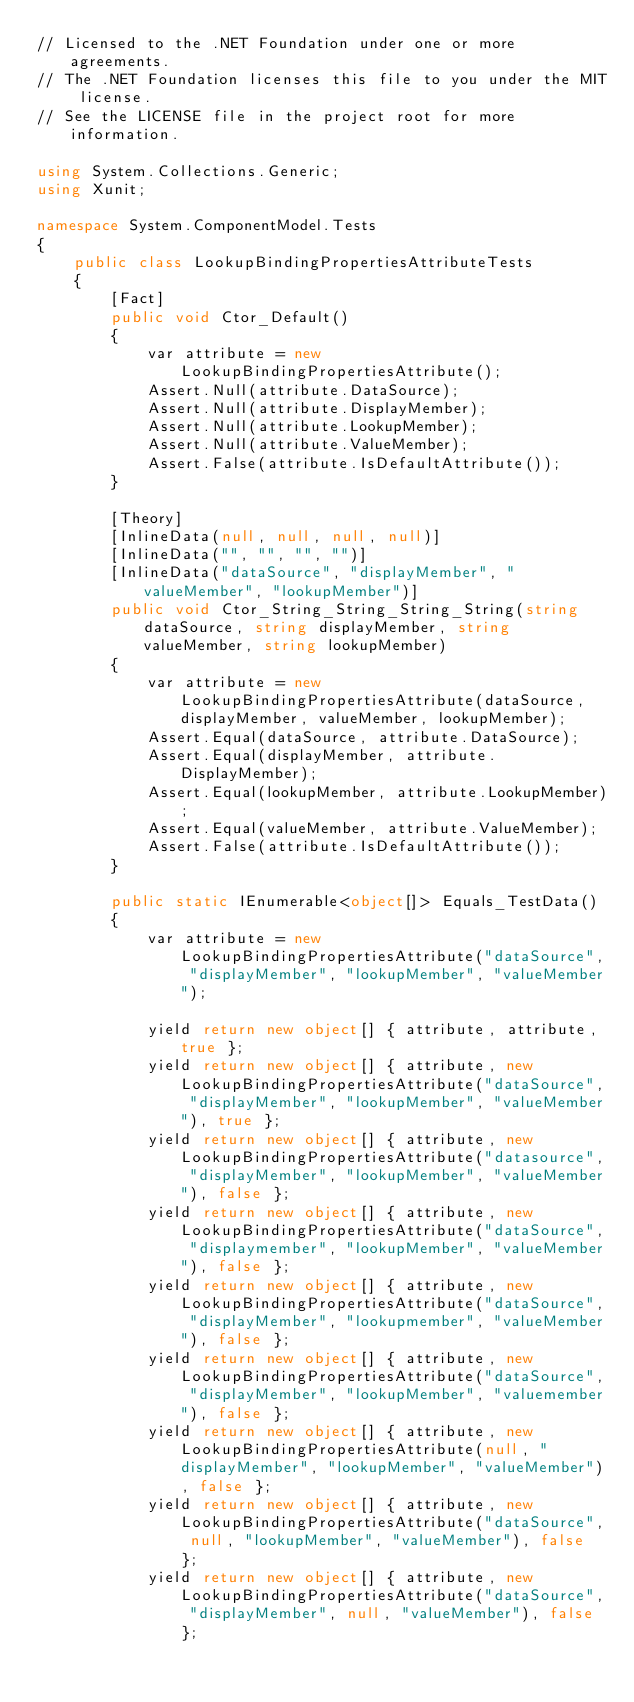<code> <loc_0><loc_0><loc_500><loc_500><_C#_>// Licensed to the .NET Foundation under one or more agreements.
// The .NET Foundation licenses this file to you under the MIT license.
// See the LICENSE file in the project root for more information.

using System.Collections.Generic;
using Xunit;

namespace System.ComponentModel.Tests
{
    public class LookupBindingPropertiesAttributeTests
    {
        [Fact]
        public void Ctor_Default()
        {
            var attribute = new LookupBindingPropertiesAttribute();
            Assert.Null(attribute.DataSource);
            Assert.Null(attribute.DisplayMember);
            Assert.Null(attribute.LookupMember);
            Assert.Null(attribute.ValueMember);
            Assert.False(attribute.IsDefaultAttribute());
        }

        [Theory]
        [InlineData(null, null, null, null)]
        [InlineData("", "", "", "")]
        [InlineData("dataSource", "displayMember", "valueMember", "lookupMember")]
        public void Ctor_String_String_String_String(string dataSource, string displayMember, string valueMember, string lookupMember)
        {
            var attribute = new LookupBindingPropertiesAttribute(dataSource, displayMember, valueMember, lookupMember);
            Assert.Equal(dataSource, attribute.DataSource);
            Assert.Equal(displayMember, attribute.DisplayMember);
            Assert.Equal(lookupMember, attribute.LookupMember);
            Assert.Equal(valueMember, attribute.ValueMember);
            Assert.False(attribute.IsDefaultAttribute());
        }

        public static IEnumerable<object[]> Equals_TestData()
        {
            var attribute = new LookupBindingPropertiesAttribute("dataSource", "displayMember", "lookupMember", "valueMember");

            yield return new object[] { attribute, attribute, true };
            yield return new object[] { attribute, new LookupBindingPropertiesAttribute("dataSource", "displayMember", "lookupMember", "valueMember"), true };
            yield return new object[] { attribute, new LookupBindingPropertiesAttribute("datasource", "displayMember", "lookupMember", "valueMember"), false };
            yield return new object[] { attribute, new LookupBindingPropertiesAttribute("dataSource", "displaymember", "lookupMember", "valueMember"), false };
            yield return new object[] { attribute, new LookupBindingPropertiesAttribute("dataSource", "displayMember", "lookupmember", "valueMember"), false };
            yield return new object[] { attribute, new LookupBindingPropertiesAttribute("dataSource", "displayMember", "lookupMember", "valuemember"), false };
            yield return new object[] { attribute, new LookupBindingPropertiesAttribute(null, "displayMember", "lookupMember", "valueMember"), false };
            yield return new object[] { attribute, new LookupBindingPropertiesAttribute("dataSource", null, "lookupMember", "valueMember"), false };
            yield return new object[] { attribute, new LookupBindingPropertiesAttribute("dataSource", "displayMember", null, "valueMember"), false };</code> 